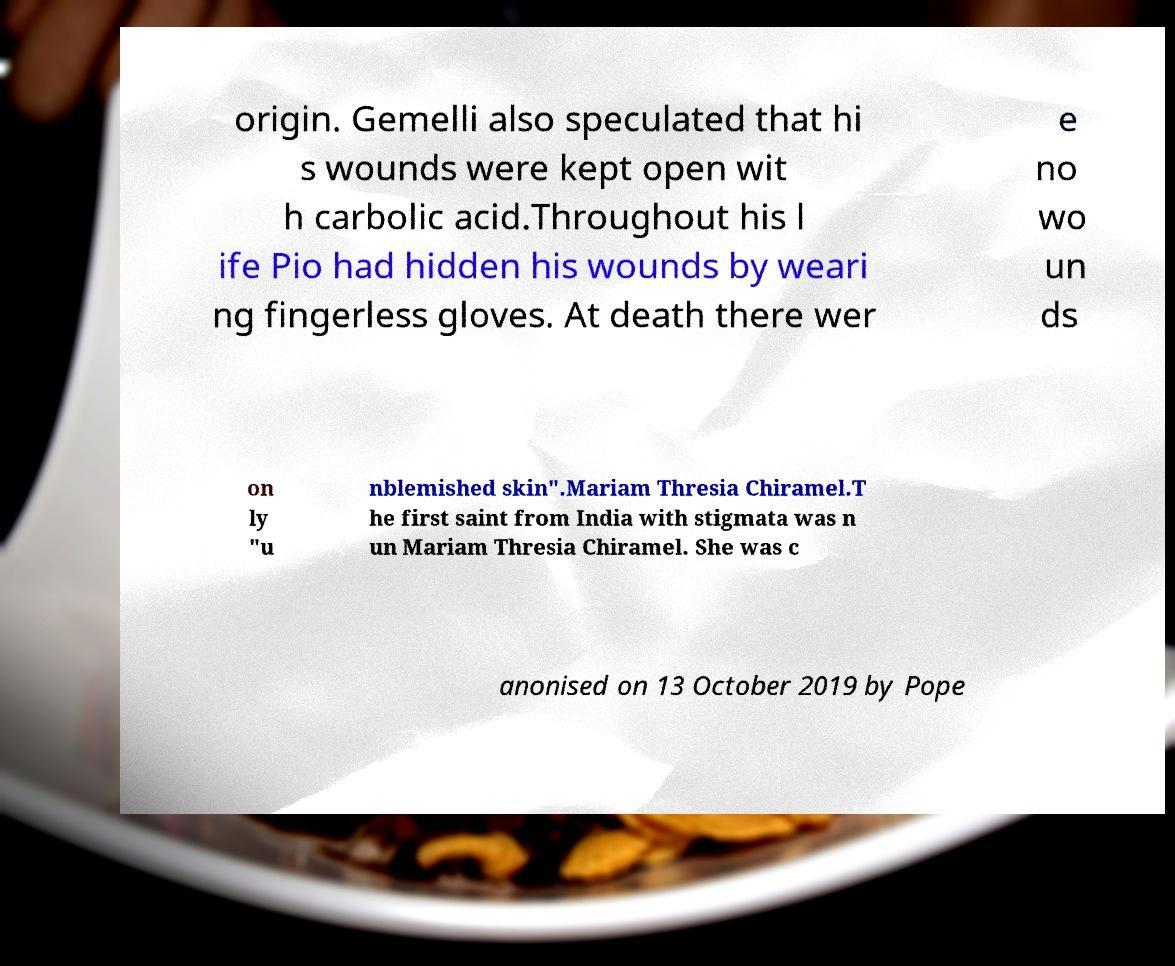Could you assist in decoding the text presented in this image and type it out clearly? origin. Gemelli also speculated that hi s wounds were kept open wit h carbolic acid.Throughout his l ife Pio had hidden his wounds by weari ng fingerless gloves. At death there wer e no wo un ds on ly "u nblemished skin".Mariam Thresia Chiramel.T he first saint from India with stigmata was n un Mariam Thresia Chiramel. She was c anonised on 13 October 2019 by Pope 